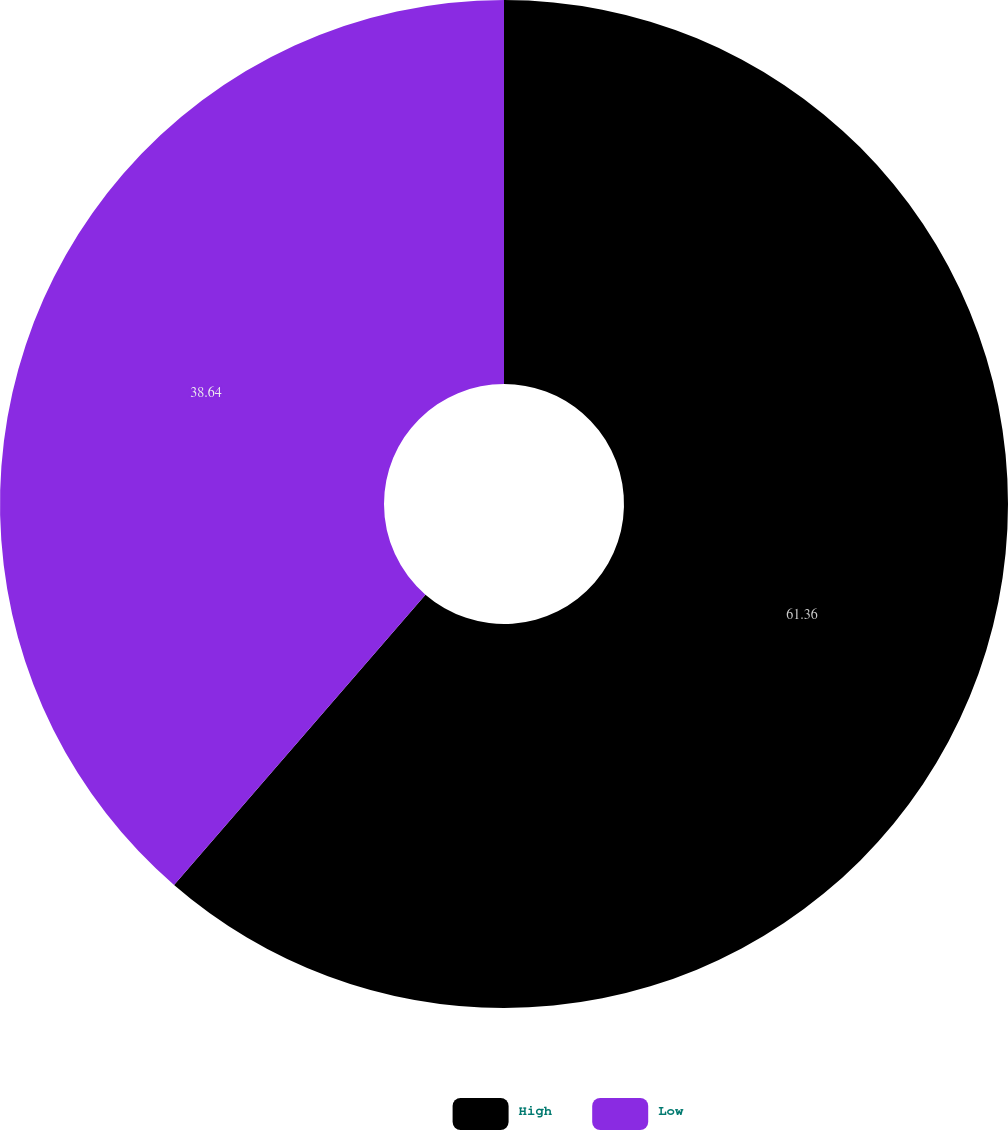Convert chart to OTSL. <chart><loc_0><loc_0><loc_500><loc_500><pie_chart><fcel>High<fcel>Low<nl><fcel>61.36%<fcel>38.64%<nl></chart> 